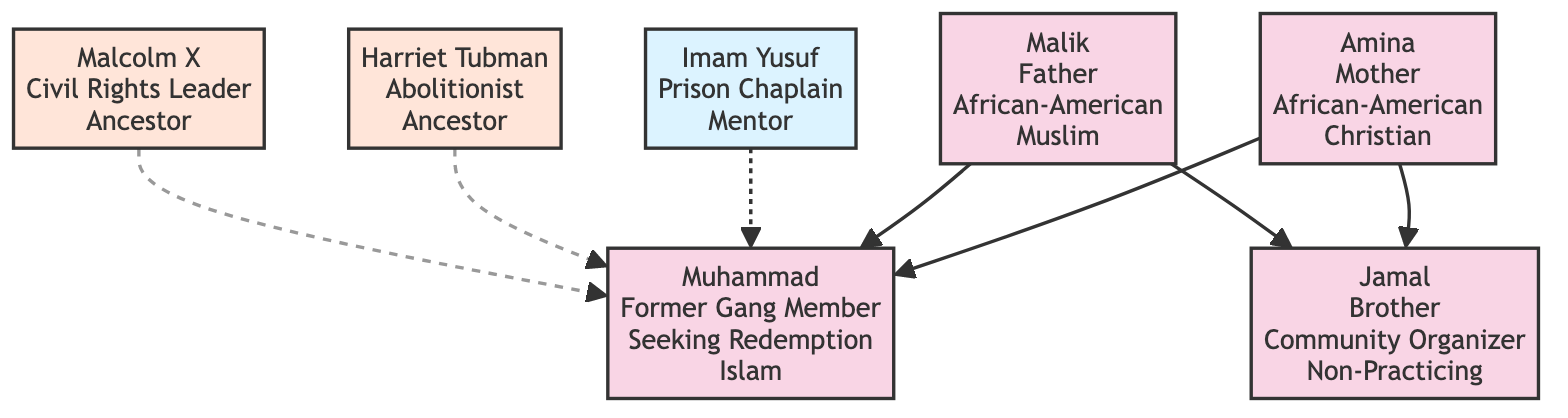What is Muhammad's religion? The diagram specifically states that Muhammad's religion is Islam, which is mentioned directly under his node.
Answer: Islam Who is Muhammad's mentor? The diagram identifies Imam Yusuf as Muhammad's mentor. His role as a prison chaplain is also highlighted in his node.
Answer: Imam Yusuf How many family members are depicted in the diagram? By counting the nodes representing family members (Amina, Malik, and Jamal), there are three family members directly connected to Muhammad.
Answer: 3 What is the relationship between Amina and Muhammad? The diagram shows a direct link labeled 'Mother' from Amina to Muhammad, indicating Amina is Muhammad's mother.
Answer: Mother Which ancestor is known as an abolitionist? The diagram clearly indicates Harriet Tubman as an ancestor with the specified role of an abolitionist in her node.
Answer: Harriet Tubman What year did Muhammad start his spiritual mentorship with Imam Yusuf? The node for Imam Yusuf indicates that the mentorship with Muhammad started in 2017, which can be found directly under his details.
Answer: 2017 What is the occupation of Muhammad's brother? The diagram states that Jamal, Muhammad's brother, is a community organizer, presented directly in his node next to his name.
Answer: Community Organizer Which verse from the Quran is mentioned as a key scripture in Muhammad's spiritual journey? The diagram lists Surah Al-Baqarah 2:286 as the key scripture under Muhammad’s spiritual journey section.
Answer: Surah Al-Baqarah 2:286 How is Malik related to Jamal? The diagram shows that Malik is connected to Jamal with a 'Father' relationship, indicating that Malik is Jamal's father as well as Muhammad's.
Answer: Father 